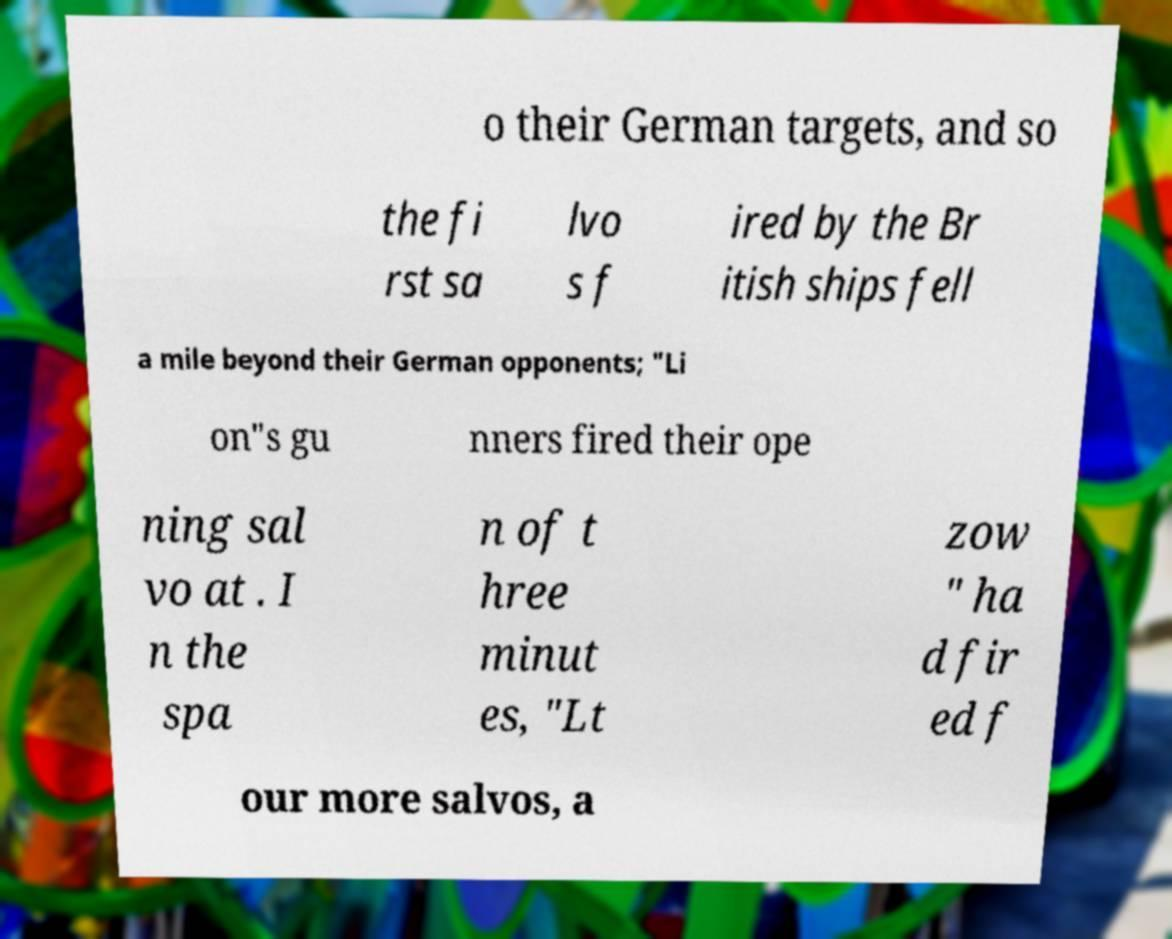Can you accurately transcribe the text from the provided image for me? o their German targets, and so the fi rst sa lvo s f ired by the Br itish ships fell a mile beyond their German opponents; "Li on"s gu nners fired their ope ning sal vo at . I n the spa n of t hree minut es, "Lt zow " ha d fir ed f our more salvos, a 